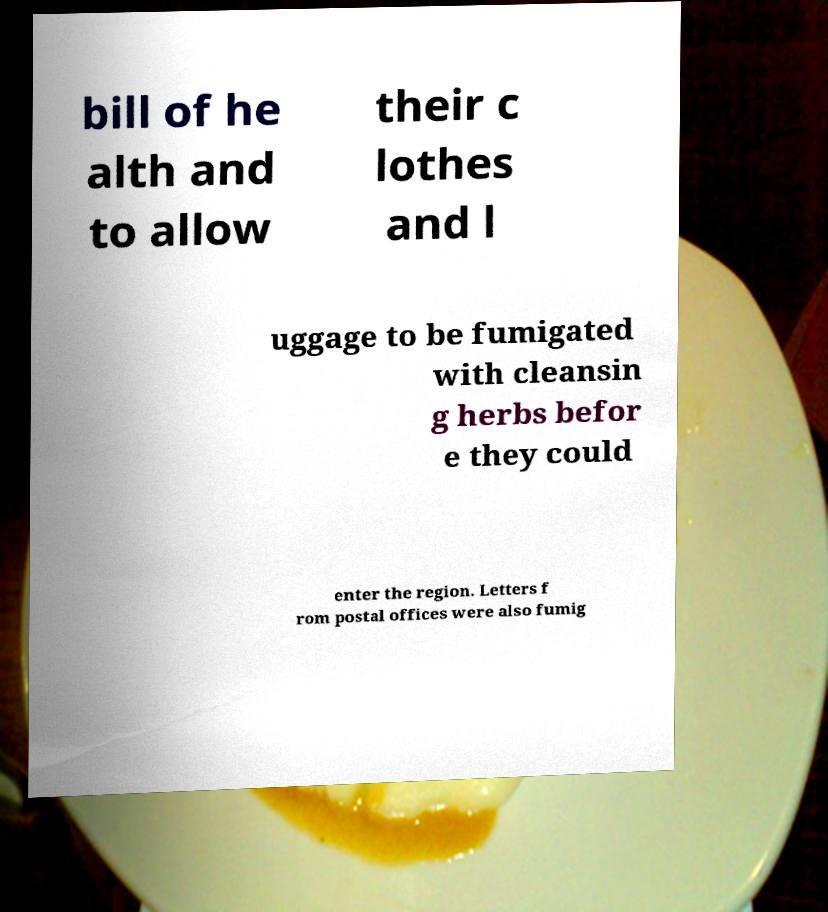What messages or text are displayed in this image? I need them in a readable, typed format. bill of he alth and to allow their c lothes and l uggage to be fumigated with cleansin g herbs befor e they could enter the region. Letters f rom postal offices were also fumig 